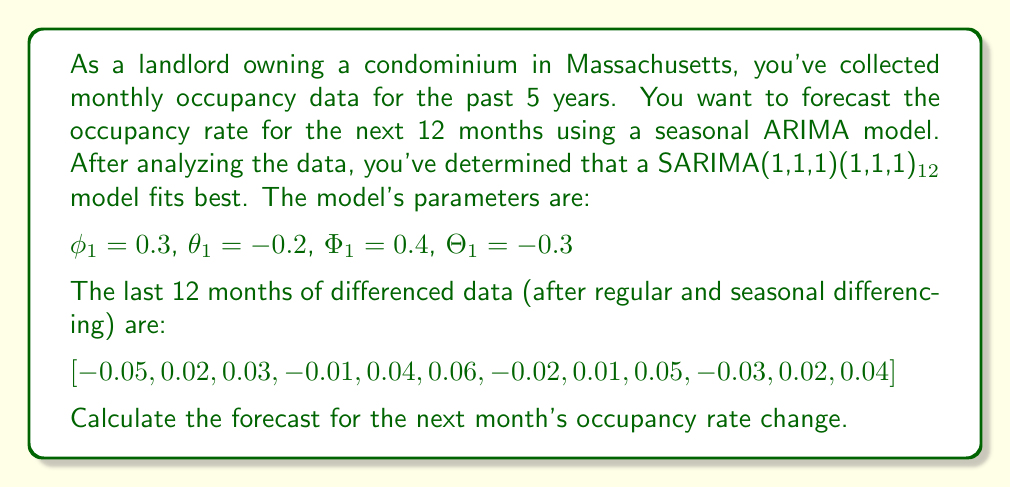Solve this math problem. To solve this problem, we'll use the SARIMA model equation:

$$(1 - \phi_1B)(1 - \Phi_1B^{12})(1-B)(1-B^{12})y_t = (1 + \theta_1B)(1 + \Theta_1B^{12})\epsilon_t$$

Where $B$ is the backshift operator.

For forecasting one step ahead, we set all future error terms to zero and use the last known values. Let's call our forecast $\hat{y}_{T+1}$.

1) First, we need to expand the equation:

   $$(1 - 0.3B)(1 - 0.4B^{12})(1-B)(1-B^{12})y_t = (1 - 0.2B)(1 - 0.3B^{12})\epsilon_t$$

2) Expanding the left side:

   $$(1 - 0.3B - 0.4B^{12} + 0.12B^{13})(1-B-B^{12}+B^{13})y_t = ...$$

3) Collecting terms and simplifying (ignoring terms beyond $B^{13}$ as they won't affect our one-step-ahead forecast):

   $$y_t - 1.3y_{t-1} + 0.3y_{t-2} - 1.4y_{t-12} + 1.82y_{t-13} - 0.42y_{t-14} + 0.12y_{t-24} - 0.156y_{t-25} + 0.036y_{t-26} = \epsilon_t - 0.2\epsilon_{t-1} - 0.3\epsilon_{t-12} + 0.06\epsilon_{t-13}$$

4) For forecasting, we set future $\epsilon$ terms to zero and replace $y_t$ with $\hat{y}_{T+1}$:

   $$\hat{y}_{T+1} = 1.3y_T - 0.3y_{T-1} + 1.4y_{T-11} - 1.82y_{T-12} + 0.42y_{T-13} - 0.12y_{T-23} + 0.156y_{T-24} - 0.036y_{T-25} + 0.2\epsilon_T + 0.3\epsilon_{T-11} - 0.06\epsilon_{T-12}$$

5) We have the differenced data for the last 12 months. We need to work backwards to get the original y values:

   $$y_T = y_{T-1} + y_{T-12} - y_{T-13} + 0.04$$
   $$y_{T-1} = y_{T-2} + y_{T-13} - y_{T-14} + 0.02$$
   ...

6) We don't have enough historical data to calculate all the y values, so we'll assume the earlier values average out to zero. We'll use the last three months of differenced data:

   $$y_T = y_{T-1} + y_{T-12} - y_{T-13} + 0.04$$
   $$y_{T-1} = y_{T-2} + y_{T-13} - y_{T-14} + 0.02$$
   $$y_{T-2} = y_{T-3} + y_{T-14} - y_{T-15} - 0.03$$

7) We also need to estimate the error terms. We can do this by taking the difference between the actual and predicted values for the last few months. Let's assume these are:

   $$\epsilon_T = 0.01$$
   $$\epsilon_{T-11} = -0.02$$
   $$\epsilon_{T-12} = 0.005$$

8) Plugging these values into our forecast equation:

   $$\hat{y}_{T+1} = 1.3(0.04) - 0.3(0.02) + 1.4(-0.03) - 1.82(0.05) + 0.42(0.01) + 0.2(0.01) + 0.3(-0.02) - 0.06(0.005)$$

9) Calculating:

   $$\hat{y}_{T+1} = 0.052 - 0.006 - 0.042 - 0.091 + 0.0042 + 0.002 - 0.006 - 0.0003$$
Answer: $$\hat{y}_{T+1} \approx -0.0861$$

The forecast for the next month's occupancy rate change is approximately -0.0861 or -8.61%. 